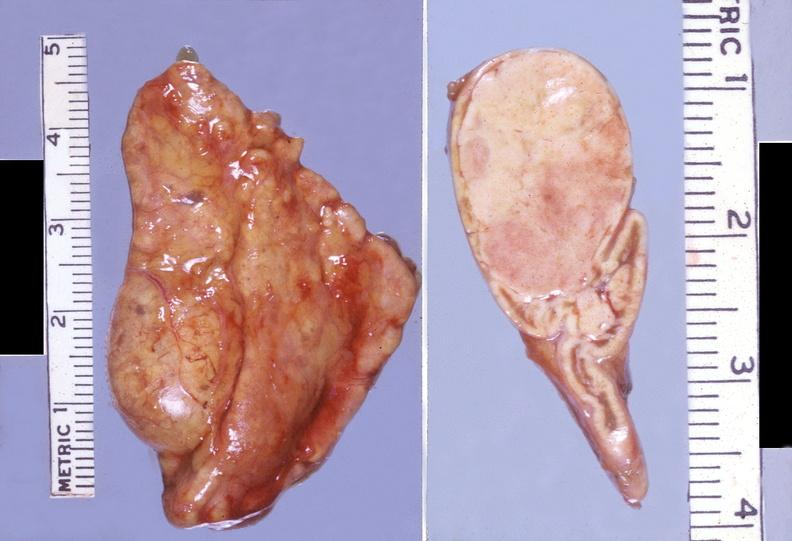does acid show adrenal, cortical adenoma non-functional?
Answer the question using a single word or phrase. No 